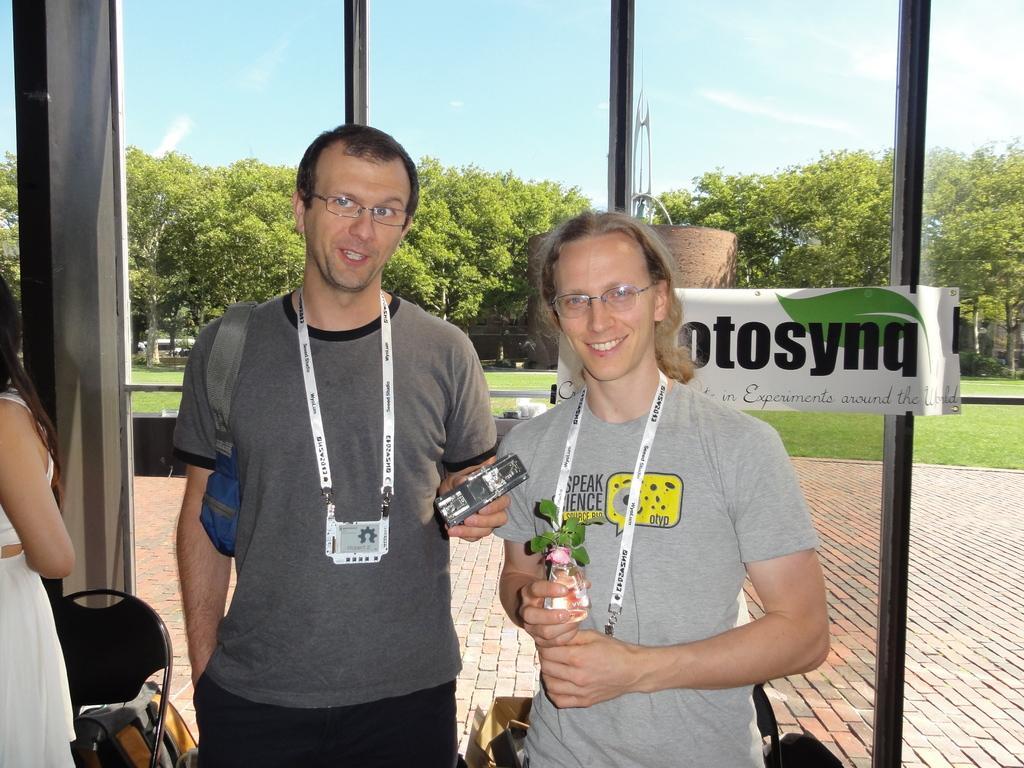In one or two sentences, can you explain what this image depicts? In the image there are two men wearing id card stood in front of a glass wall,behind the glass there are trees,grass and sky filled with clouds over the top. 